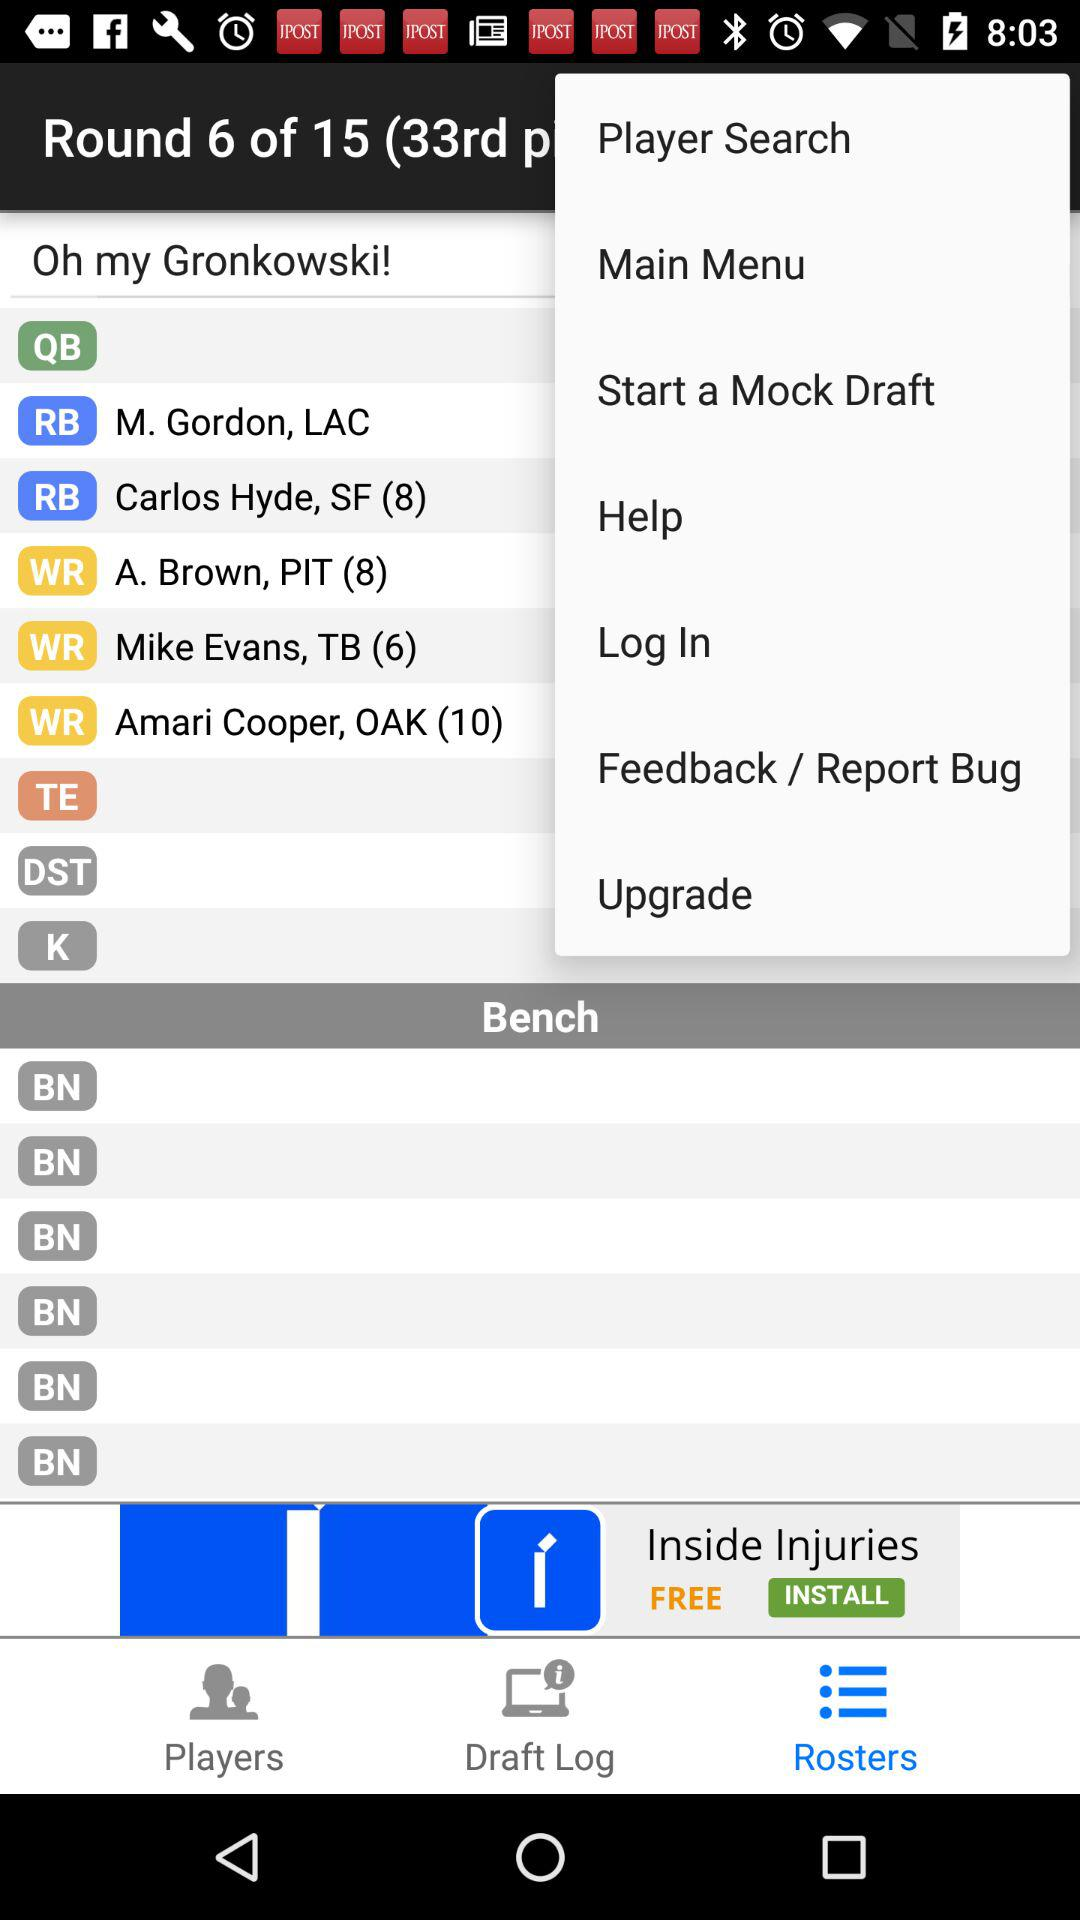What is the status of "Log In"?
When the provided information is insufficient, respond with <no answer>. <no answer> 